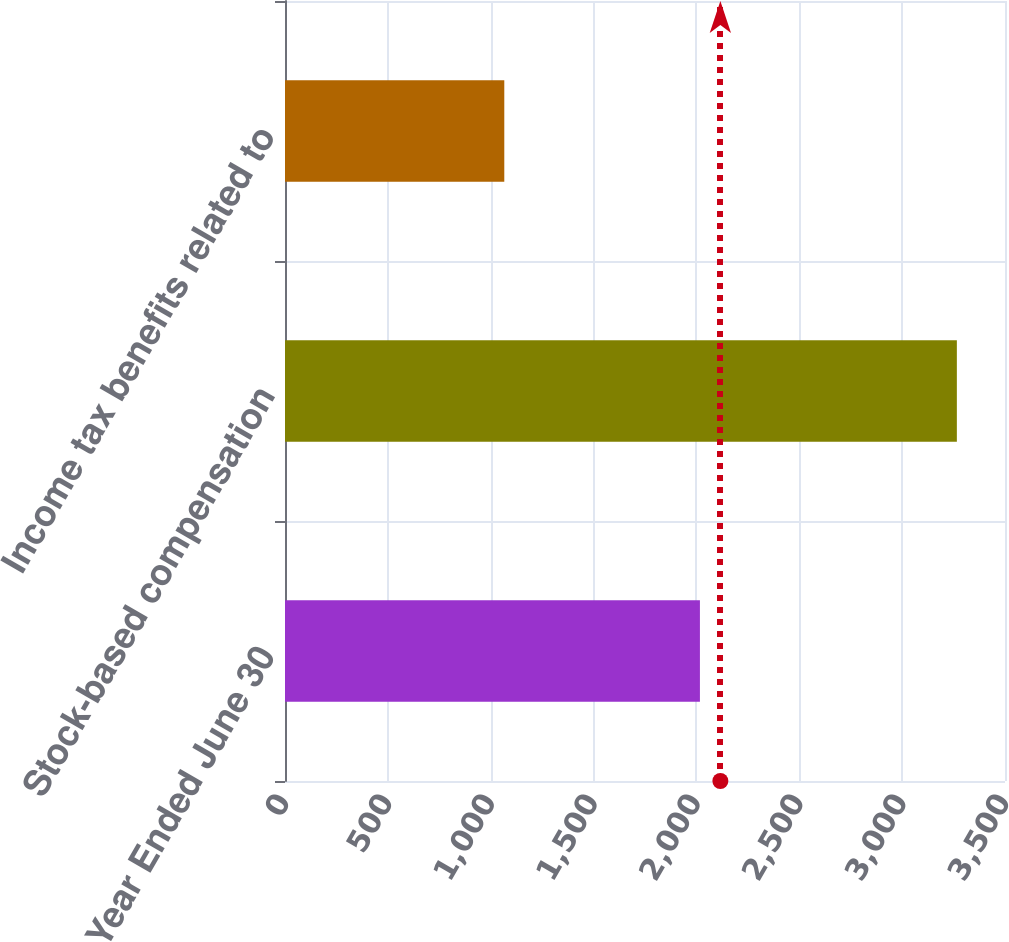Convert chart to OTSL. <chart><loc_0><loc_0><loc_500><loc_500><bar_chart><fcel>Year Ended June 30<fcel>Stock-based compensation<fcel>Income tax benefits related to<nl><fcel>2017<fcel>3266<fcel>1066<nl></chart> 